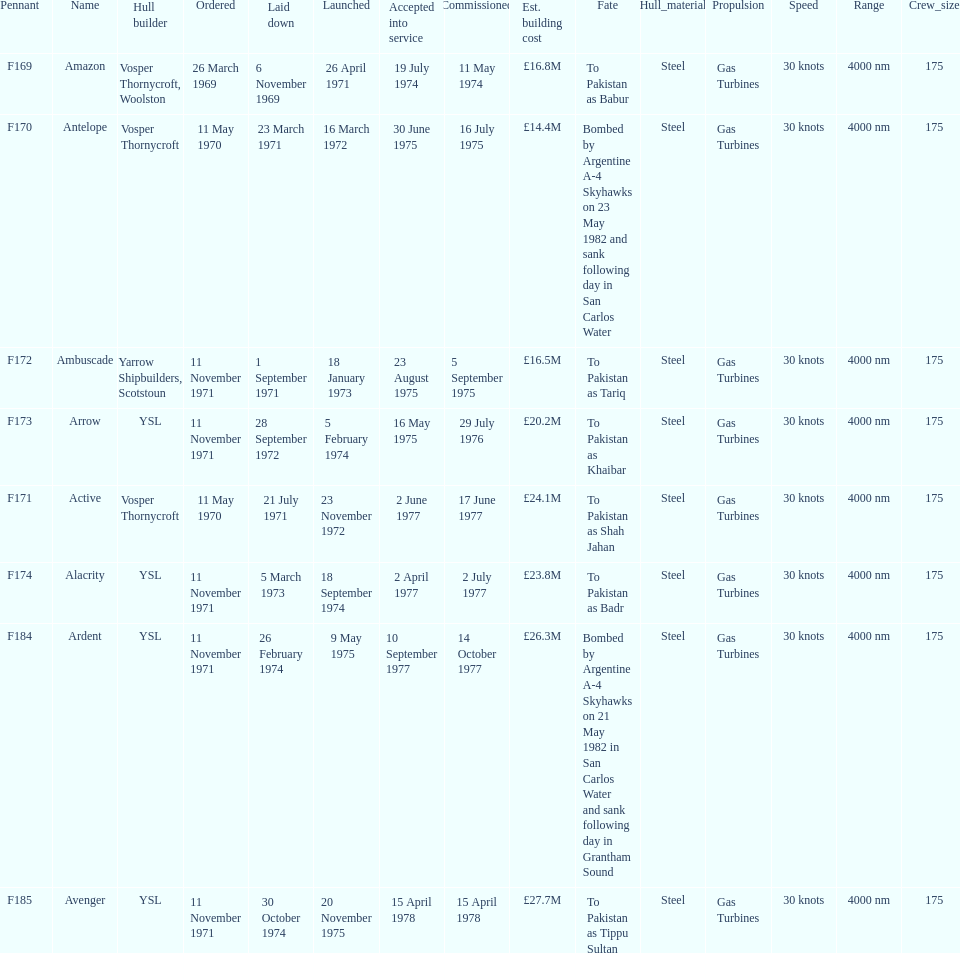What is the last listed pennant? F185. 